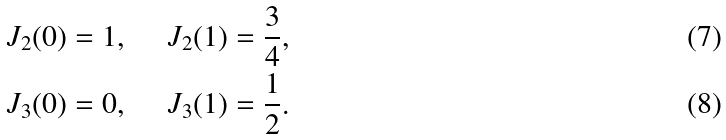<formula> <loc_0><loc_0><loc_500><loc_500>& \ J _ { 2 } ( 0 ) = 1 , \quad \ J _ { 2 } ( 1 ) = \frac { 3 } { 4 } , \\ & \ J _ { 3 } ( 0 ) = 0 , \quad \ J _ { 3 } ( 1 ) = \frac { 1 } { 2 } .</formula> 